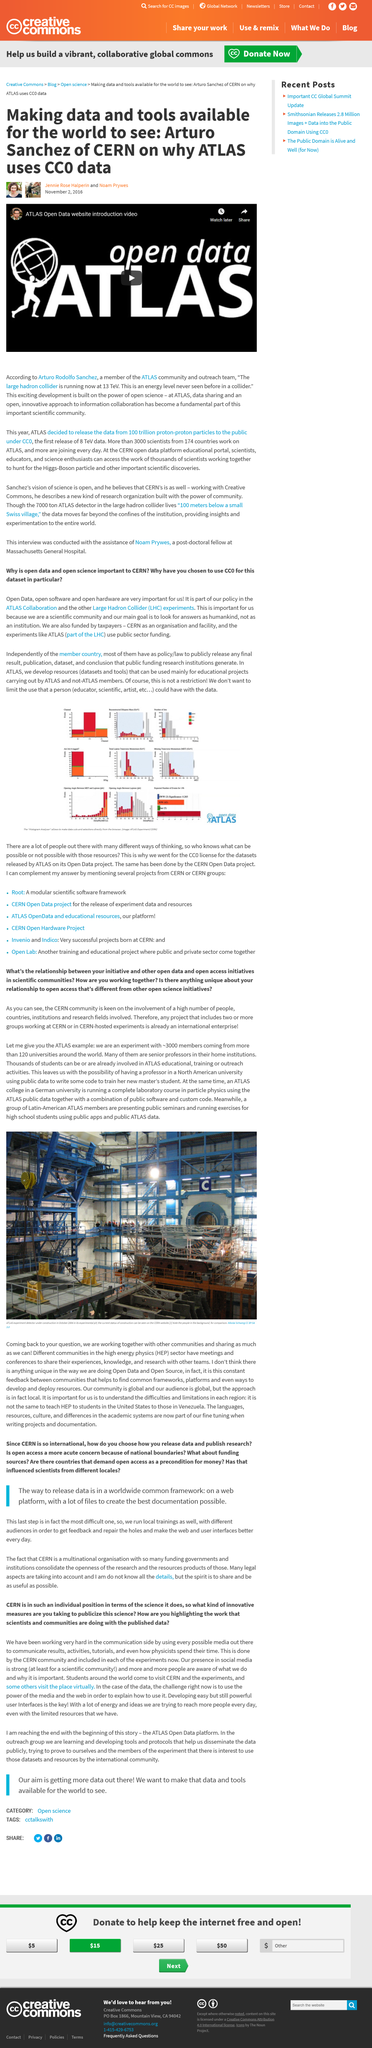List a handful of essential elements in this visual. The Large Hadron Collider at ATLAS operates at an energy level of 13 TeV, as stated by Arturo Sanchez. CERN's presence in social media is undeniably strong, as evidenced by the numerous followers, likes, and shares it has amassed on various online platforms. ATLAS uses CC0 data, which is a type of open data that is freely available for anyone to use, modify, and distribute, without any restrictions on use. Arturo Rodolfo Sanchez is a member of the ATLAS community and outreach team who holds the job title of [insert job title here]. CERN is visited by students from around the world, who come to learn about cutting-edge physics and technology. 